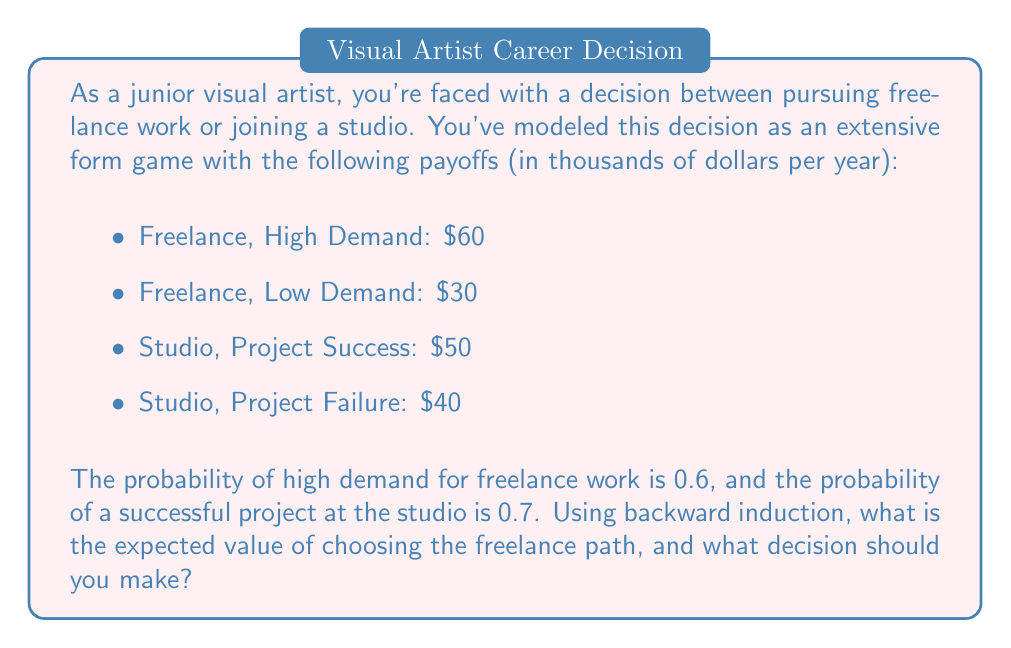What is the answer to this math problem? Let's approach this problem using backward induction in extensive form games:

1) First, we need to calculate the expected value of each path:

   For the freelance path:
   $$E(\text{Freelance}) = 0.6 \times 60 + 0.4 \times 30 = 36 + 12 = 48$$

   For the studio path:
   $$E(\text{Studio}) = 0.7 \times 50 + 0.3 \times 40 = 35 + 12 = 47$$

2) The extensive form game can be represented as follows:

   [asy]
   import geometry;

   size(200,150);

   pair A=(0,0), B=(100,50), C=(100,-50), D=(200,75), E=(200,25), F=(200,-25), G=(200,-75);

   draw(A--B--D);
   draw(B--E);
   draw(A--C--F);
   draw(C--G);

   dot(A); dot(B); dot(C); dot(D); dot(E); dot(F); dot(G);

   label("You", A, W);
   label("Freelance", B, N);
   label("Studio", C, S);
   label("High (0.6)", D, E);
   label("Low (0.4)", E, E);
   label("Success (0.7)", F, E);
   label("Failure (0.3)", G, E);
   label("60", D, N);
   label("30", E, N);
   label("50", F, N);
   label("40", G, N);
   label("48", B, SW);
   label("47", C, NW);
   [/asy]

3) The expected value of choosing the freelance path is $48,000 per year, as calculated in step 1.

4) To make the decision, we compare the expected values:
   
   Freelance: $48,000
   Studio: $47,000

   Since the expected value of freelance work is higher, you should choose the freelance path.
Answer: The expected value of choosing the freelance path is $48,000 per year. Based on the expected values, you should choose to pursue freelance work. 